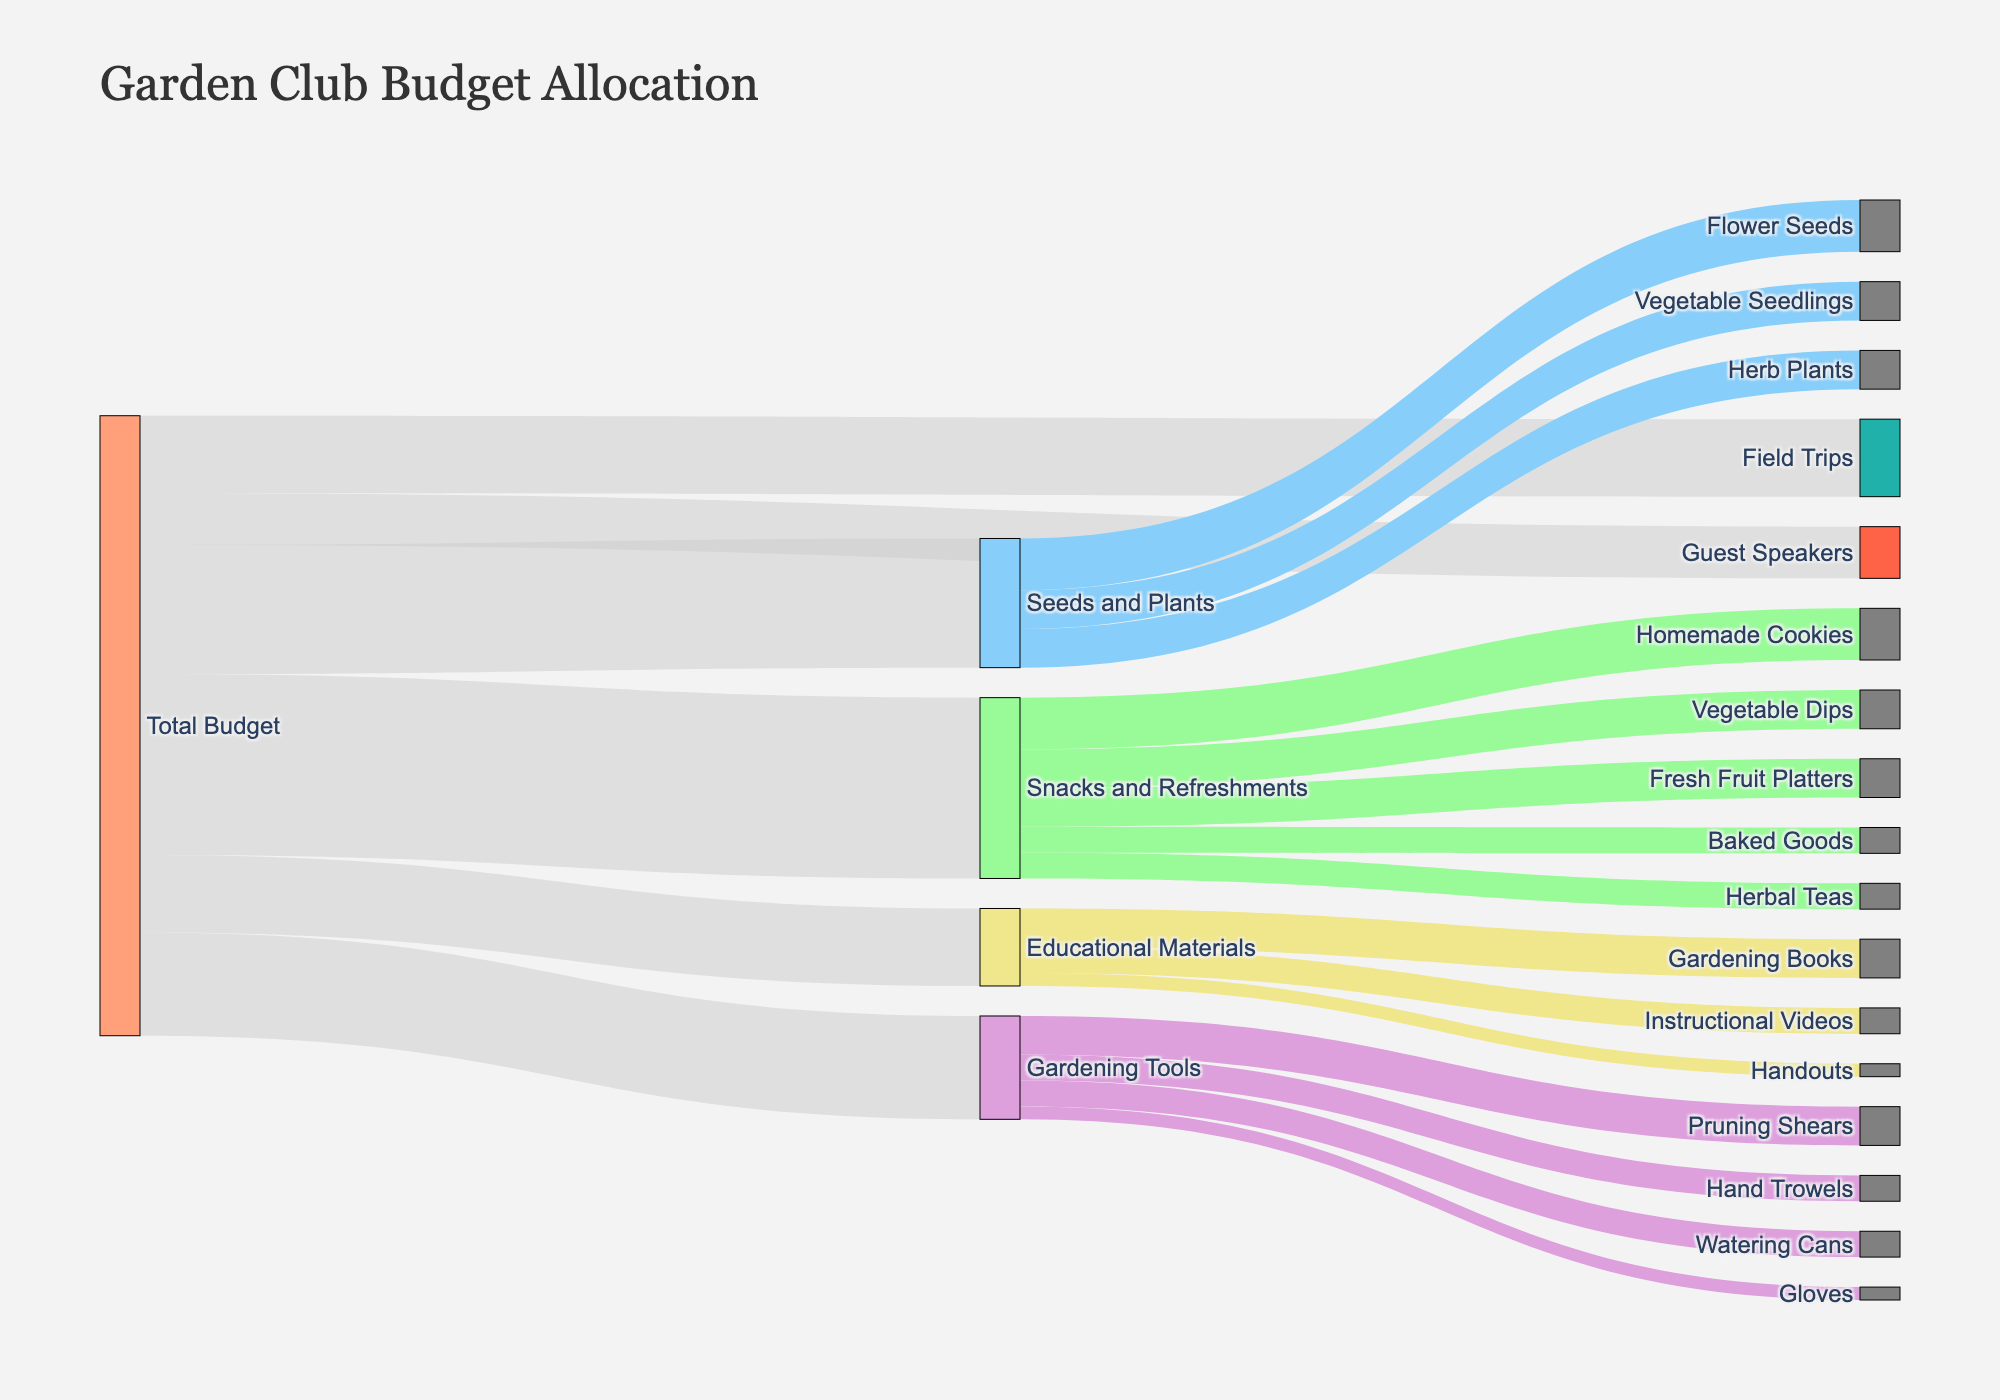What's the total budget allocated to Snacks and Refreshments? Identify the segment "Snacks and Refreshments" linked from "Total Budget" and look at the associated value.
Answer: 350 Name the categories under Snacks and Refreshments. Trace the links from "Snacks and Refreshments" to see all its subcategories. These are: "Homemade Cookies," "Fresh Fruit Platters," "Herbal Teas," "Vegetable Dips," and "Baked Goods."
Answer: Homemade Cookies, Fresh Fruit Platters, Herbal Teas, Vegetable Dips, Baked Goods What is the total value allocated to Educational Materials and Field Trips combined? Identify the values for "Educational Materials" and "Field Trips." Add these values together: 150 + 150.
Answer: 300 Which subcategory of Snacks and Refreshments got the highest budget? Look at all the subcategories connected to "Snacks and Refreshments" and compare their values. "Homemade Cookies" has the maximum value of 100.
Answer: Homemade Cookies Compare the budget of Gardening Tools with Seeds and Plants. Which one has a higher allocation and by how much? Check the values for "Gardening Tools" and "Seeds and Plants": 200 for Gardening Tools and 250 for Seeds and Plants. The difference is 250 - 200.
Answer: Seeds and Plants, by 50 What percentage of the total budget is allocated to Guest Speakers? Identify the total budget (1150) and the amount allocated to "Guest Speakers" (100). Calculate the percentage: (100 / 1150) * 100.
Answer: ~8.7% How much more is allocated to Field Trips compared to Guest Speakers? Identify the values for "Field Trips" and "Guest Speakers." Calculate the difference: 150 - 100.
Answer: 50 Which category has the smallest allocation from the total budget? Look at all the categories linked to "Total Budget." "Guest Speakers" has the smallest value of 100.
Answer: Guest Speakers What is the total value allocated to Flower Seeds, Vegetable Seedlings, and Herb Plants? Identify and sum the values for "Flower Seeds," "Vegetable Seedlings," and "Herb Plants." The values are: 100 + 75 + 75.
Answer: 250 Compare the total budget allocated to Gardening Tools with the combined budget of Hand Trowels and Pruning Shears. Which is greater and by how much? Identify the budget for "Gardening Tools" (200), and sum the budgets for "Hand Trowels" and "Pruning Shears" (50 + 75 = 125). Then calculate the difference: 200 - 125.
Answer: Gardening Tools, by 75 